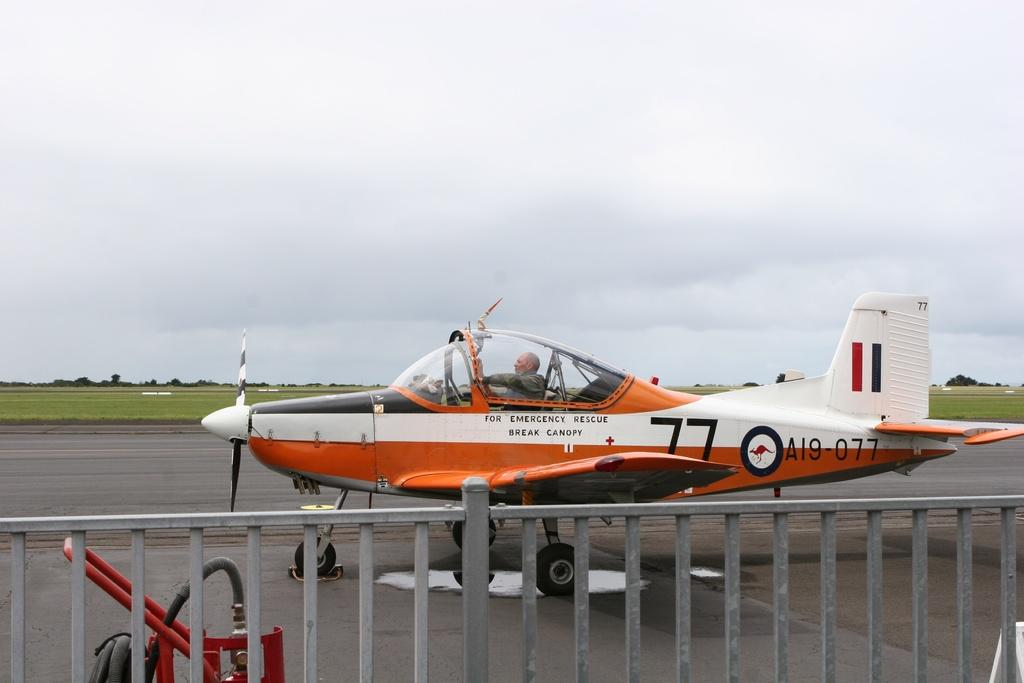Provide a one-sentence caption for the provided image. A plane, that is numbered A19 077, is on a runway. 